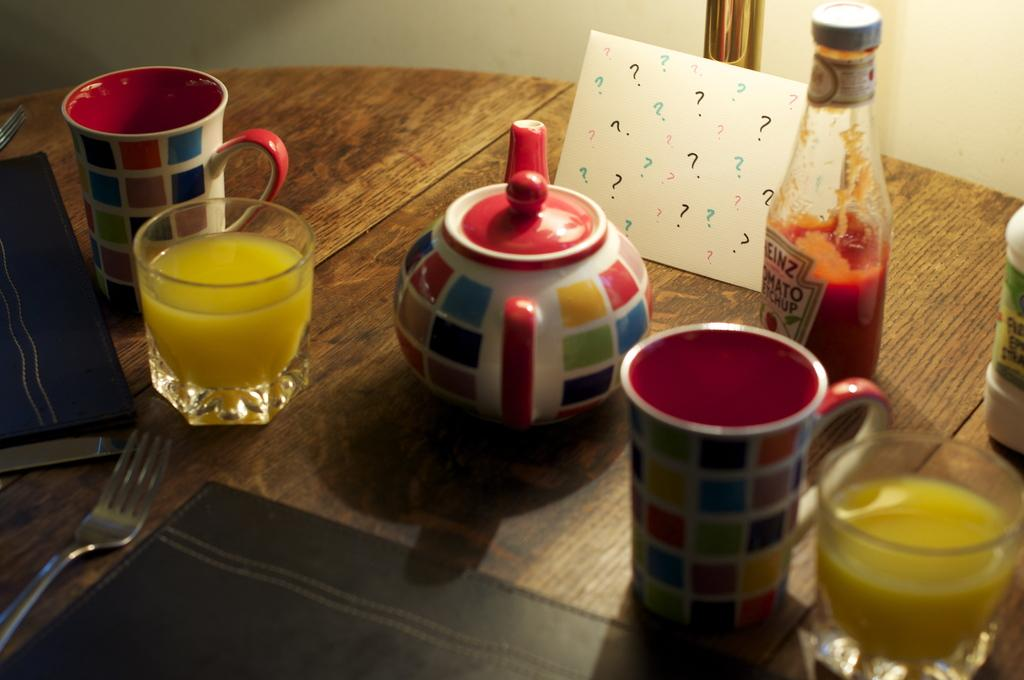What type of utensil is present in the image? There is a fork in the image. What type of container is present in the image? There is a glass, a flask, and a bottle in the image. What type of furniture is present in the image? There is a cupboard in the image. What type of object is present on the table in the image? There is a book on the table in the image. How many companies are present in the image? There are no companies present in the image. What is the mass of the thumb in the image? There is no thumb present in the image. 